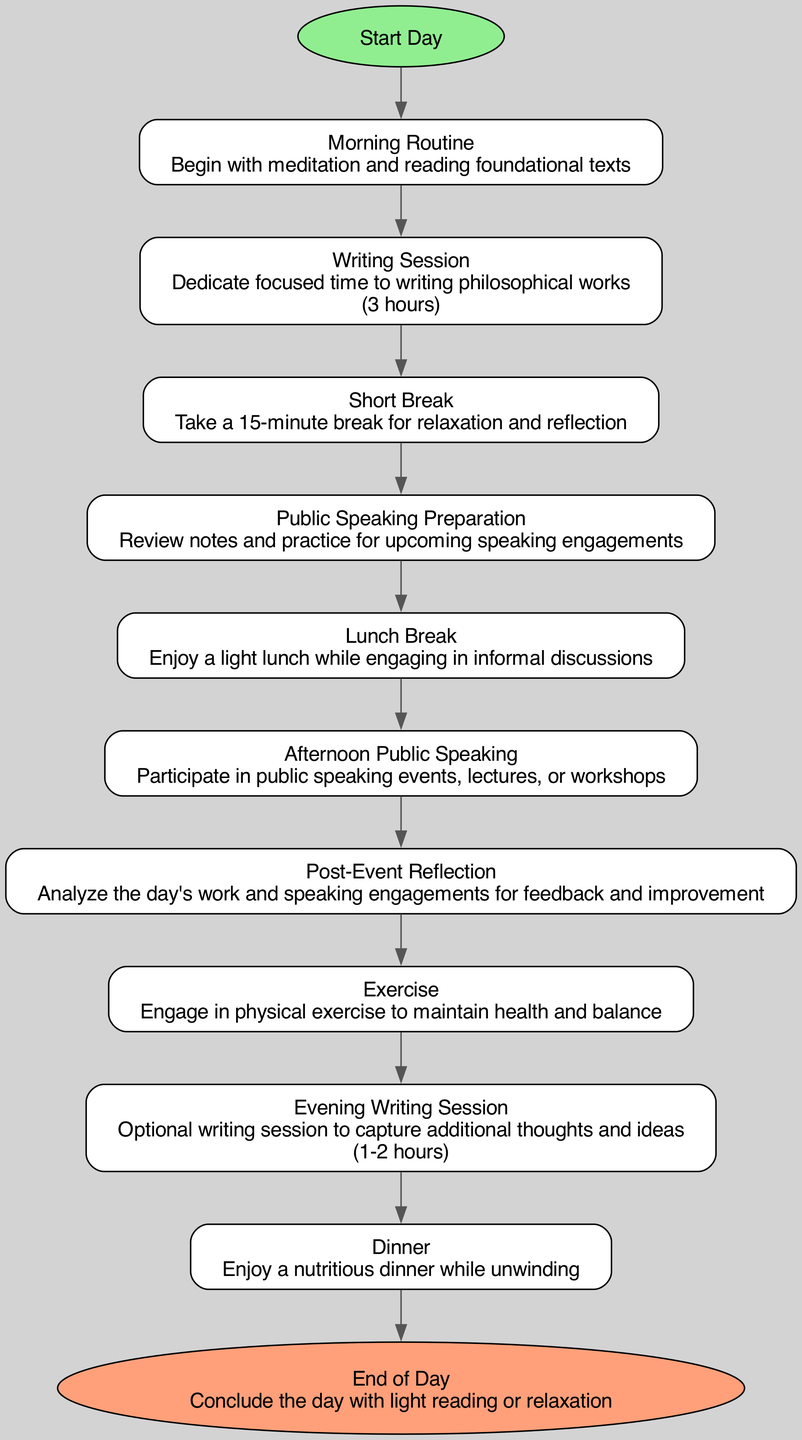What is the first action in the flowchart? The first action listed in the flowchart is following the start node, which leads directly to the "Morning Routine" node.
Answer: Morning Routine How long is the writing session? "Writing Session" in the flowchart specifies a duration of "3 hours," which is directly noted in the description of the action.
Answer: 3 hours What follows the "Short Break"? The flowchart shows a direct connection from "Short Break" to "Public Speaking Preparation," indicating that this action immediately follows.
Answer: Public Speaking Preparation How many action steps are in the flowchart? By counting all the action nodes in the flowchart, there are a total of nine actions, starting from "Morning Routine" to "Evening Writing Session," prior to the end of the day.
Answer: 9 What is the relationship between "Post-Event Reflection" and "Exercise"? The flowchart illustrates that "Post-Event Reflection" leads directly to "Exercise," showing a sequential relationship between reflecting on the day's events and engaging in physical activity.
Answer: Sequential What is the last activity before "End of Day"? Analyzing the connections in the flowchart, the last activity before reaching the "End of Day" node is the "Dinner" node, which is the preceding action.
Answer: Dinner What is the purpose of the "Public Speaking Preparation" step? This step is explicitly designated for reviewing notes and practicing for upcoming speaking engagements, as stated in its description in the flowchart.
Answer: Review notes and practice How does physical exercise fit into the daily routine? Following "Post-Event Reflection," the flowchart indicates that the next step is "Exercise," suggesting it is integrated after a period of reflection on work and speaking engagements to balance the day's demands.
Answer: Balance What kind of reading concludes the day? The last node before the flowchart ends specifies that the day concludes with "light reading or relaxation," indicating a gentle transition into rest.
Answer: Light reading or relaxation 